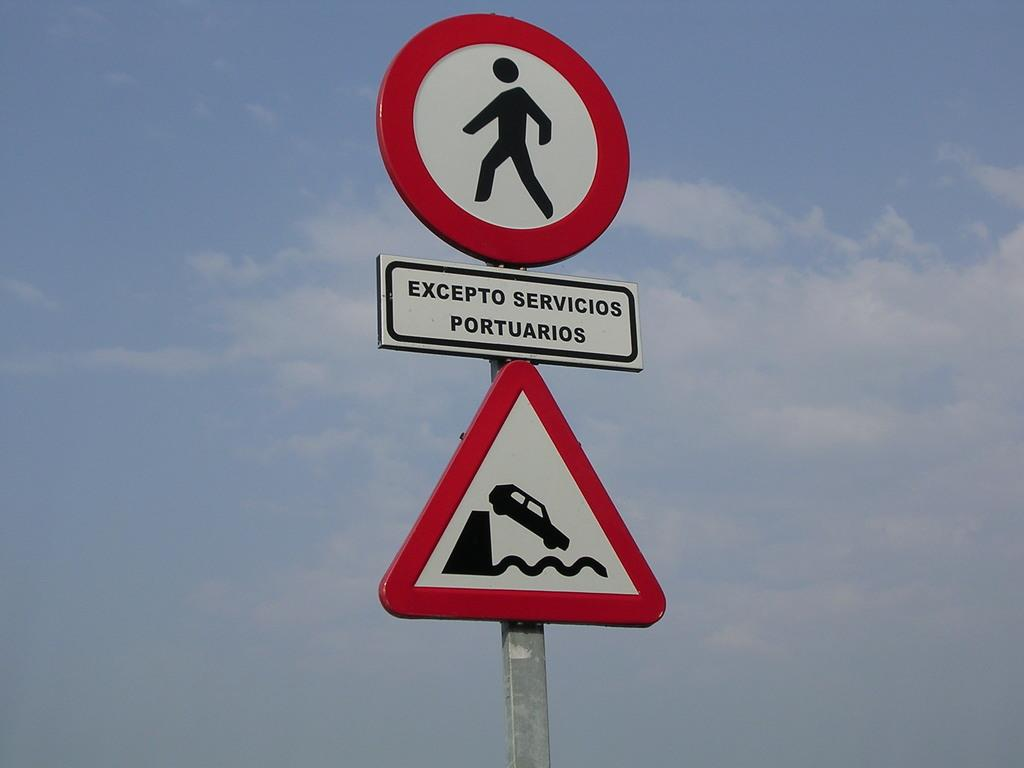What is the main object in the image? There is a signage board in the image. What information is displayed on the signage board? There are words written on the signage board. What can be seen in the background of the image? The sky is visible in the background of the image. How would you describe the weather based on the sky in the image? The sky appears to be clear, suggesting good weather. Where is the park located in the image? There is no park present in the image. What type of fruit is hanging from the signage board in the image? There is no fruit present in the image, and the signage board is not a tree or a structure where fruit would typically grow. 